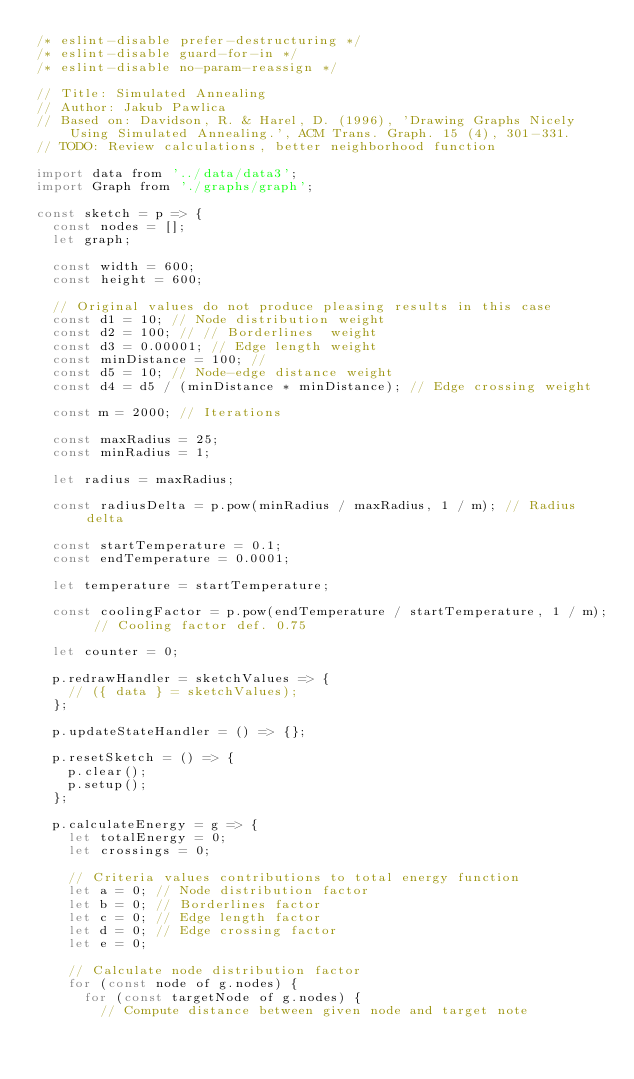Convert code to text. <code><loc_0><loc_0><loc_500><loc_500><_JavaScript_>/* eslint-disable prefer-destructuring */
/* eslint-disable guard-for-in */
/* eslint-disable no-param-reassign */

// Title: Simulated Annealing
// Author: Jakub Pawlica
// Based on: Davidson, R. & Harel, D. (1996), 'Drawing Graphs Nicely Using Simulated Annealing.', ACM Trans. Graph. 15 (4), 301-331.
// TODO: Review calculations, better neighborhood function

import data from '../data/data3';
import Graph from './graphs/graph';

const sketch = p => {
  const nodes = [];
  let graph;

  const width = 600;
  const height = 600;

  // Original values do not produce pleasing results in this case
  const d1 = 10; // Node distribution weight
  const d2 = 100; // // Borderlines  weight
  const d3 = 0.00001; // Edge length weight
  const minDistance = 100; //
  const d5 = 10; // Node-edge distance weight
  const d4 = d5 / (minDistance * minDistance); // Edge crossing weight

  const m = 2000; // Iterations

  const maxRadius = 25;
  const minRadius = 1;

  let radius = maxRadius;

  const radiusDelta = p.pow(minRadius / maxRadius, 1 / m); // Radius delta

  const startTemperature = 0.1;
  const endTemperature = 0.0001;

  let temperature = startTemperature;

  const coolingFactor = p.pow(endTemperature / startTemperature, 1 / m); // Cooling factor def. 0.75

  let counter = 0;

  p.redrawHandler = sketchValues => {
    // ({ data } = sketchValues);
  };

  p.updateStateHandler = () => {};

  p.resetSketch = () => {
    p.clear();
    p.setup();
  };

  p.calculateEnergy = g => {
    let totalEnergy = 0;
    let crossings = 0;

    // Criteria values contributions to total energy function
    let a = 0; // Node distribution factor
    let b = 0; // Borderlines factor
    let c = 0; // Edge length factor
    let d = 0; // Edge crossing factor
    let e = 0;

    // Calculate node distribution factor
    for (const node of g.nodes) {
      for (const targetNode of g.nodes) {
        // Compute distance between given node and target note</code> 